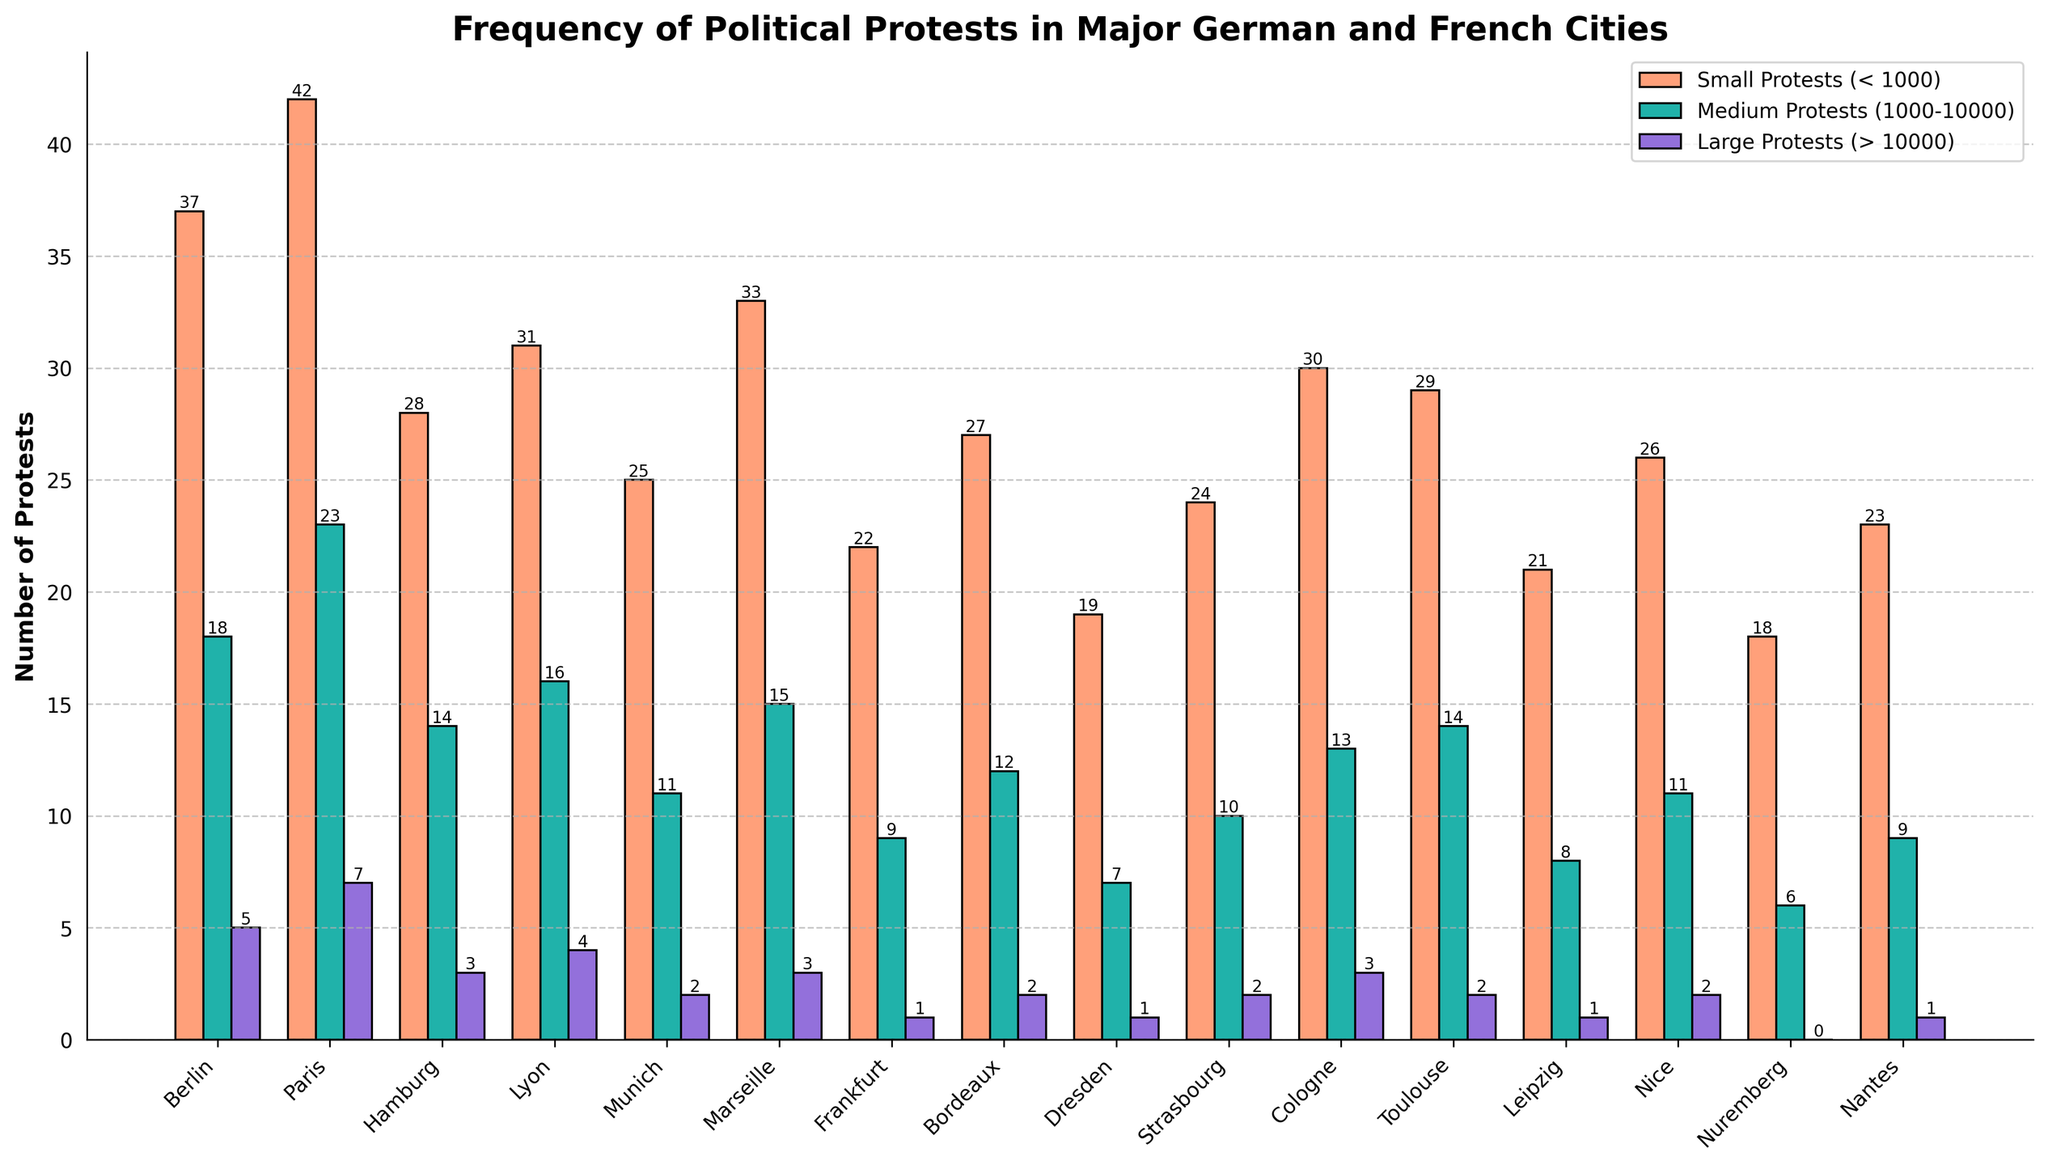Which city has the most small protests? By observing the heights of the bars labeled "Small Protests" for each city, Paris has the tallest bar, indicating the highest number of small protests.
Answer: Paris Which city has the fewest large protests? By examining the height of the bars labeled "Large Protests" for each city, Nuremberg has no visible bar, indicating zero large protests.
Answer: Nuremberg Which city has more total protests, Berlin or Marseille? Sum the values of small, medium, and large protests for both cities: Berlin (37 + 18 + 5 = 60), Marseille (33 + 15 + 3 = 51). Berlin has more total protests.
Answer: Berlin How many more medium protests does Paris have compared to Lyon? Subtract the number of medium protests in Lyon from Paris: Paris (23) - Lyon (16) = 7.
Answer: 7 What is the combined total of small and large protests in Munich? Add the number of small protests and large protests in Munich: Small (25) + Large (2) = 27.
Answer: 27 Which city has the highest difference between small and medium protests? Calculate the differences for each city and compare: Paris (42 - 23 = 19), Berlin (37 - 18 = 19), and others. Paris and Berlin have the highest difference of 19 each.
Answer: Paris and Berlin How many medium protests are there in total across all cities? Sum the number of medium protests for all cities: 18 + 23 + 14 + 16 + 11 + 15 + 9 + 12 + 7 + 10 + 13 + 14 + 8 + 11 + 6 + 9 = 190.
Answer: 190 Which city has fewer medium protests, Munich or Marseille? Compare the bars for medium protests: Munich (11), Marseille (15). Munich has fewer.
Answer: Munich What is the average number of small protests per French city? Identify French cities and calculate the average of small protests: (42 + 31 + 33 + 27 + 24 + 29 + 26 + 23)/8. Total is 235, so average is 235/8 = 29.375.
Answer: 29.375 What is the total number of protests in Strasbourg? Sum the numbers for small, medium, and large protests in Strasbourg: 24 + 10 + 2 = 36.
Answer: 36 